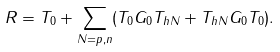Convert formula to latex. <formula><loc_0><loc_0><loc_500><loc_500>R = T _ { 0 } + \sum _ { N = p , n } ( T _ { 0 } G _ { 0 } T _ { h N } + T _ { h N } G _ { 0 } T _ { 0 } ) .</formula> 